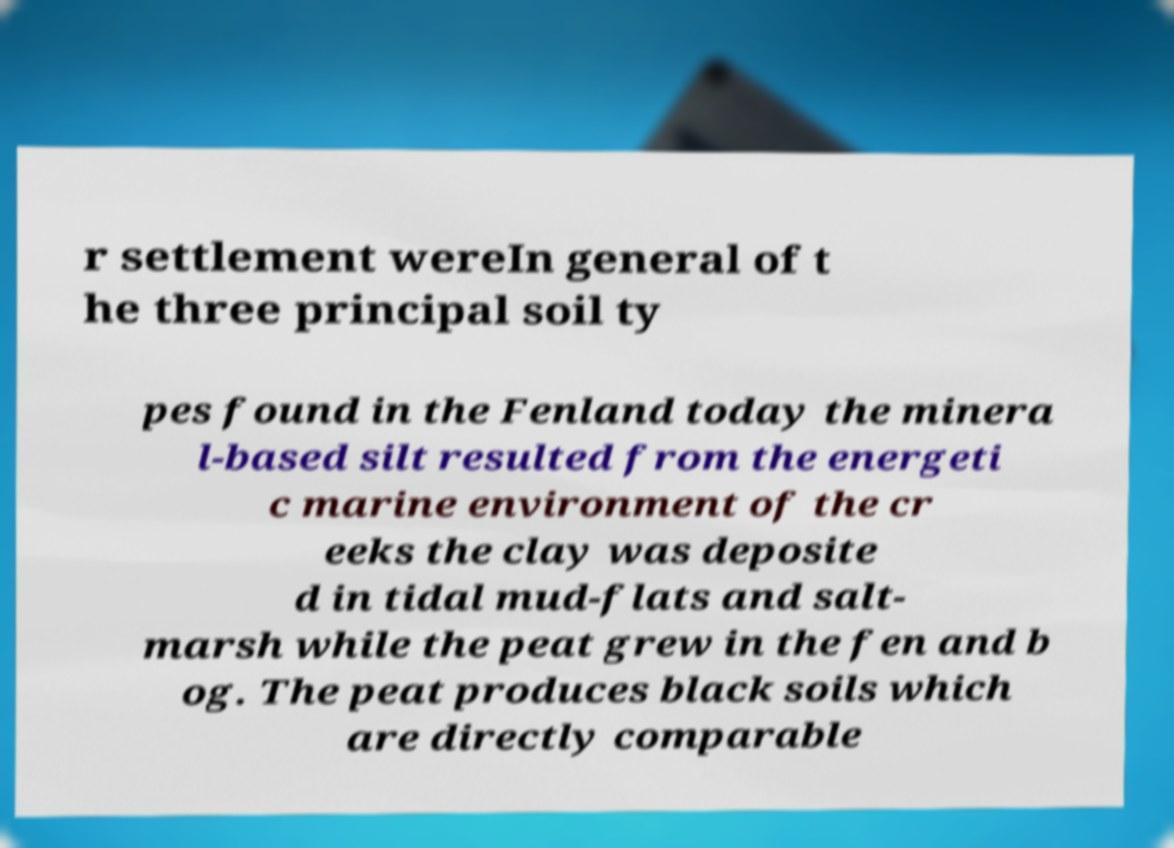Please identify and transcribe the text found in this image. r settlement wereIn general of t he three principal soil ty pes found in the Fenland today the minera l-based silt resulted from the energeti c marine environment of the cr eeks the clay was deposite d in tidal mud-flats and salt- marsh while the peat grew in the fen and b og. The peat produces black soils which are directly comparable 